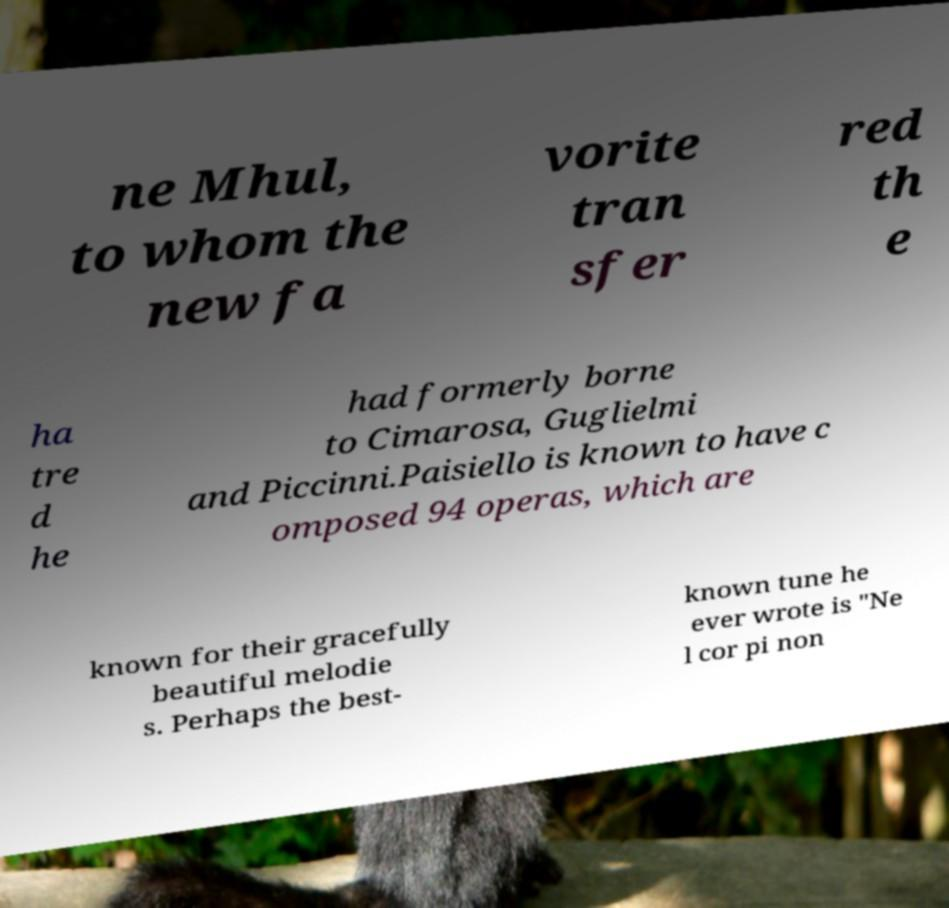For documentation purposes, I need the text within this image transcribed. Could you provide that? ne Mhul, to whom the new fa vorite tran sfer red th e ha tre d he had formerly borne to Cimarosa, Guglielmi and Piccinni.Paisiello is known to have c omposed 94 operas, which are known for their gracefully beautiful melodie s. Perhaps the best- known tune he ever wrote is "Ne l cor pi non 